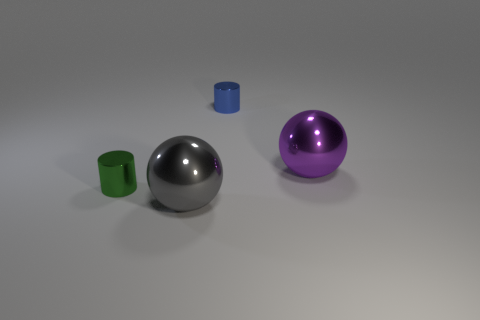Add 2 purple metal objects. How many objects exist? 6 Subtract all tiny yellow spheres. Subtract all tiny objects. How many objects are left? 2 Add 3 purple shiny spheres. How many purple shiny spheres are left? 4 Add 3 big rubber cylinders. How many big rubber cylinders exist? 3 Subtract 0 blue balls. How many objects are left? 4 